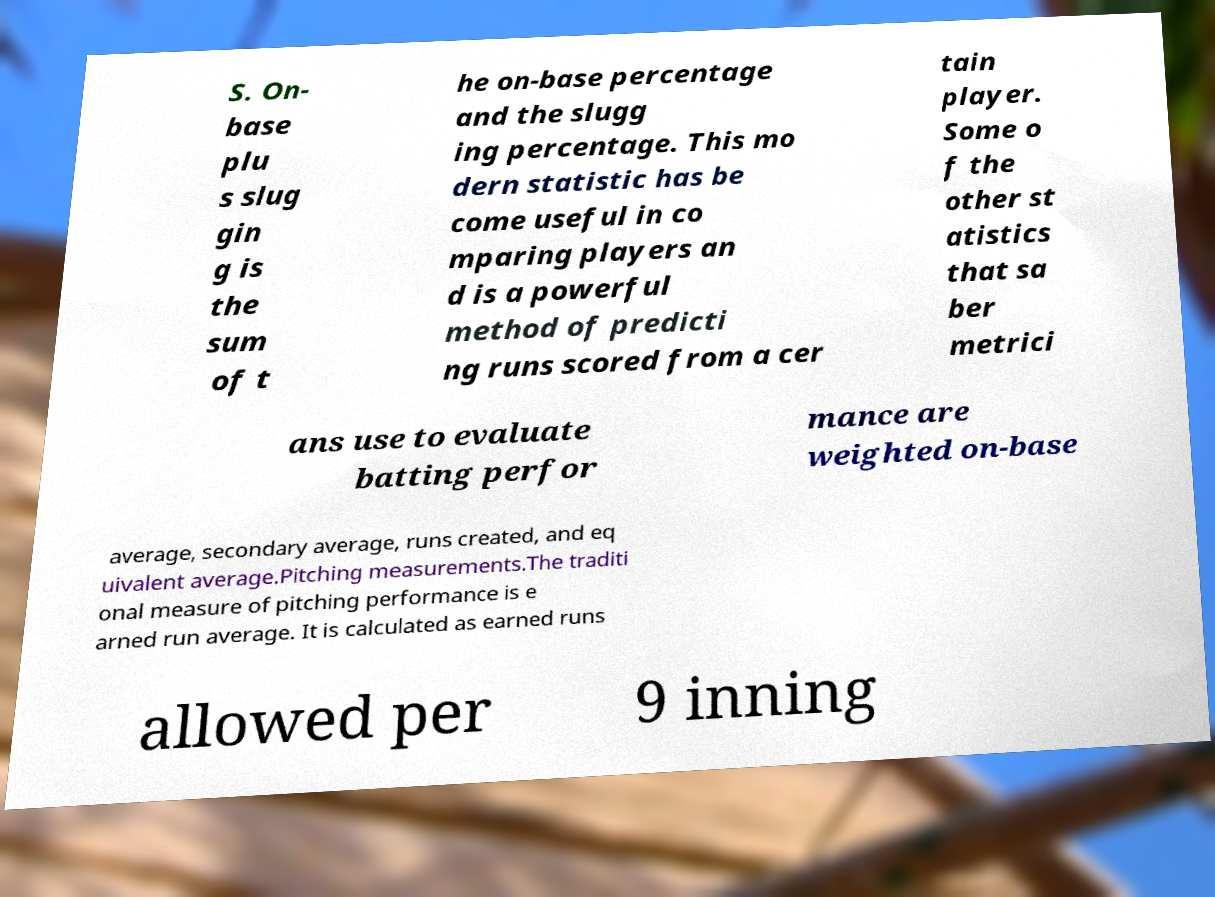Please read and relay the text visible in this image. What does it say? S. On- base plu s slug gin g is the sum of t he on-base percentage and the slugg ing percentage. This mo dern statistic has be come useful in co mparing players an d is a powerful method of predicti ng runs scored from a cer tain player. Some o f the other st atistics that sa ber metrici ans use to evaluate batting perfor mance are weighted on-base average, secondary average, runs created, and eq uivalent average.Pitching measurements.The traditi onal measure of pitching performance is e arned run average. It is calculated as earned runs allowed per 9 inning 